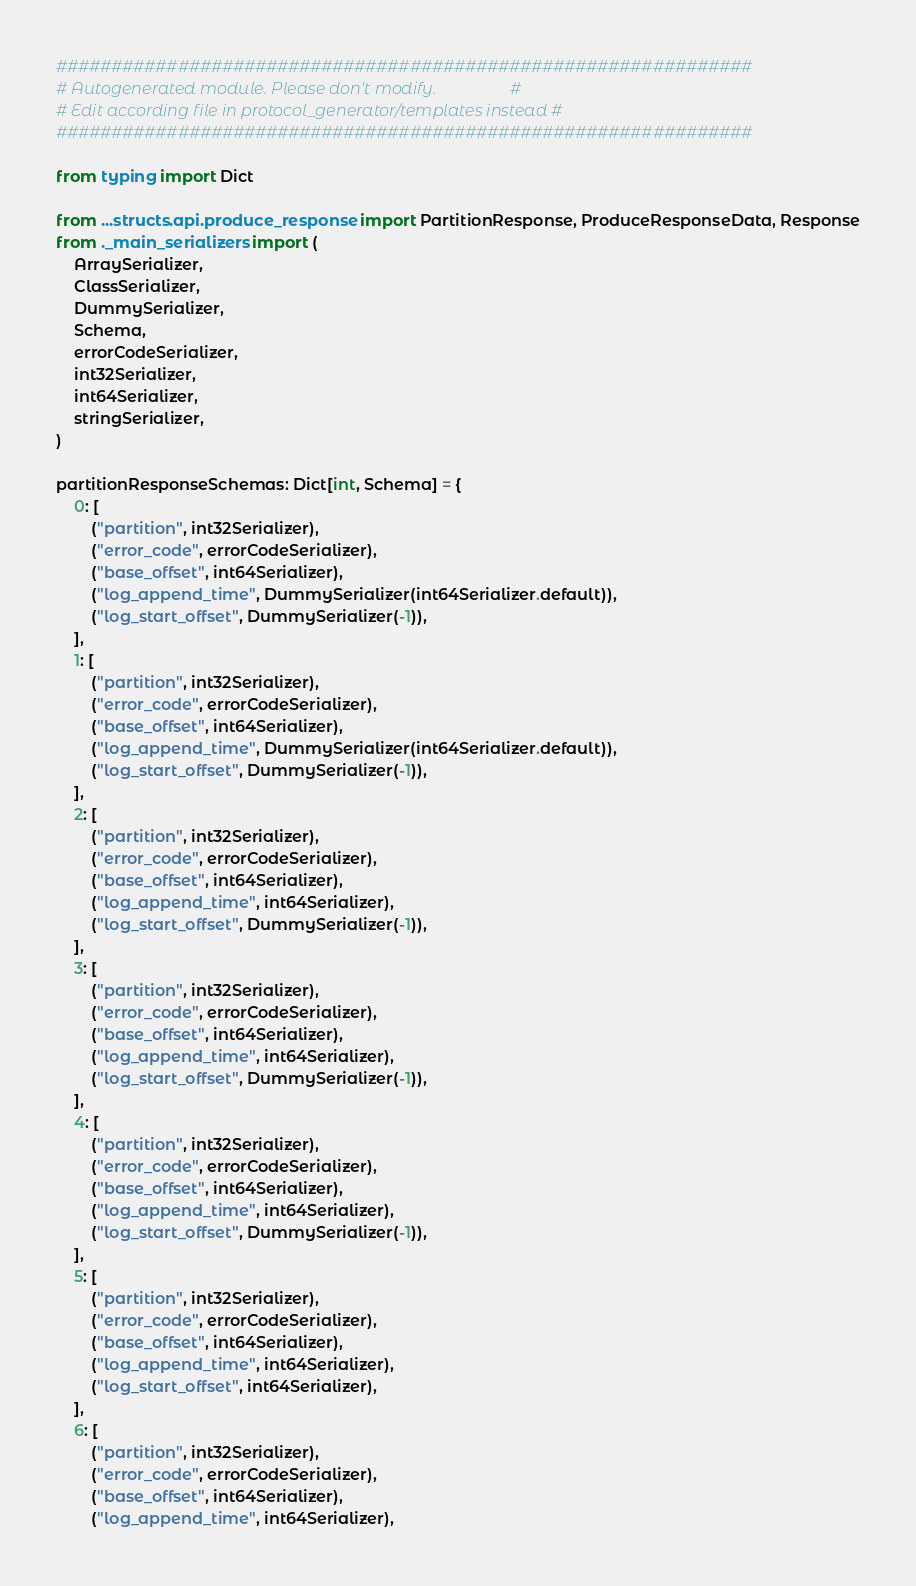<code> <loc_0><loc_0><loc_500><loc_500><_Python_>###############################################################
# Autogenerated module. Please don't modify.                  #
# Edit according file in protocol_generator/templates instead #
###############################################################

from typing import Dict

from ...structs.api.produce_response import PartitionResponse, ProduceResponseData, Response
from ._main_serializers import (
    ArraySerializer,
    ClassSerializer,
    DummySerializer,
    Schema,
    errorCodeSerializer,
    int32Serializer,
    int64Serializer,
    stringSerializer,
)

partitionResponseSchemas: Dict[int, Schema] = {
    0: [
        ("partition", int32Serializer),
        ("error_code", errorCodeSerializer),
        ("base_offset", int64Serializer),
        ("log_append_time", DummySerializer(int64Serializer.default)),
        ("log_start_offset", DummySerializer(-1)),
    ],
    1: [
        ("partition", int32Serializer),
        ("error_code", errorCodeSerializer),
        ("base_offset", int64Serializer),
        ("log_append_time", DummySerializer(int64Serializer.default)),
        ("log_start_offset", DummySerializer(-1)),
    ],
    2: [
        ("partition", int32Serializer),
        ("error_code", errorCodeSerializer),
        ("base_offset", int64Serializer),
        ("log_append_time", int64Serializer),
        ("log_start_offset", DummySerializer(-1)),
    ],
    3: [
        ("partition", int32Serializer),
        ("error_code", errorCodeSerializer),
        ("base_offset", int64Serializer),
        ("log_append_time", int64Serializer),
        ("log_start_offset", DummySerializer(-1)),
    ],
    4: [
        ("partition", int32Serializer),
        ("error_code", errorCodeSerializer),
        ("base_offset", int64Serializer),
        ("log_append_time", int64Serializer),
        ("log_start_offset", DummySerializer(-1)),
    ],
    5: [
        ("partition", int32Serializer),
        ("error_code", errorCodeSerializer),
        ("base_offset", int64Serializer),
        ("log_append_time", int64Serializer),
        ("log_start_offset", int64Serializer),
    ],
    6: [
        ("partition", int32Serializer),
        ("error_code", errorCodeSerializer),
        ("base_offset", int64Serializer),
        ("log_append_time", int64Serializer),</code> 